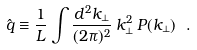<formula> <loc_0><loc_0><loc_500><loc_500>\hat { q } \equiv \frac { 1 } { L } \int \frac { d ^ { 2 } k _ { \perp } } { ( 2 \pi ) ^ { 2 } } \, k _ { \perp } ^ { 2 } \, P ( k _ { \perp } ) \ .</formula> 